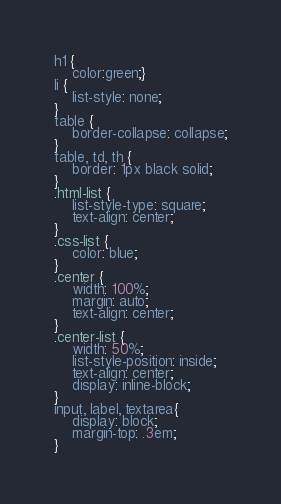Convert code to text. <code><loc_0><loc_0><loc_500><loc_500><_CSS_>h1 {
	color:green;}
li {
	list-style: none;
}
table {
	border-collapse: collapse;
}
table, td, th {
	border: 1px black solid;
}
.html-list {
	list-style-type: square;
	text-align: center;
}
.css-list {
	color: blue;
}
.center {
	width: 100%;
	margin: auto;
	text-align: center;
}
.center-list {
	width: 50%;
	list-style-position: inside;
	text-align: center;
	display: inline-block;
}
input, label, textarea{
	display: block;
	margin-top: .3em;
}</code> 